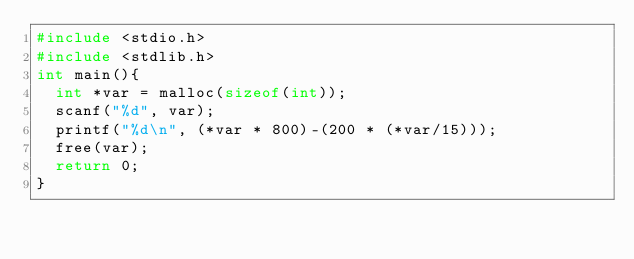<code> <loc_0><loc_0><loc_500><loc_500><_C_>#include <stdio.h>
#include <stdlib.h>
int main(){
  int *var = malloc(sizeof(int));
  scanf("%d", var);
  printf("%d\n", (*var * 800)-(200 * (*var/15)));
  free(var);
  return 0;
}</code> 